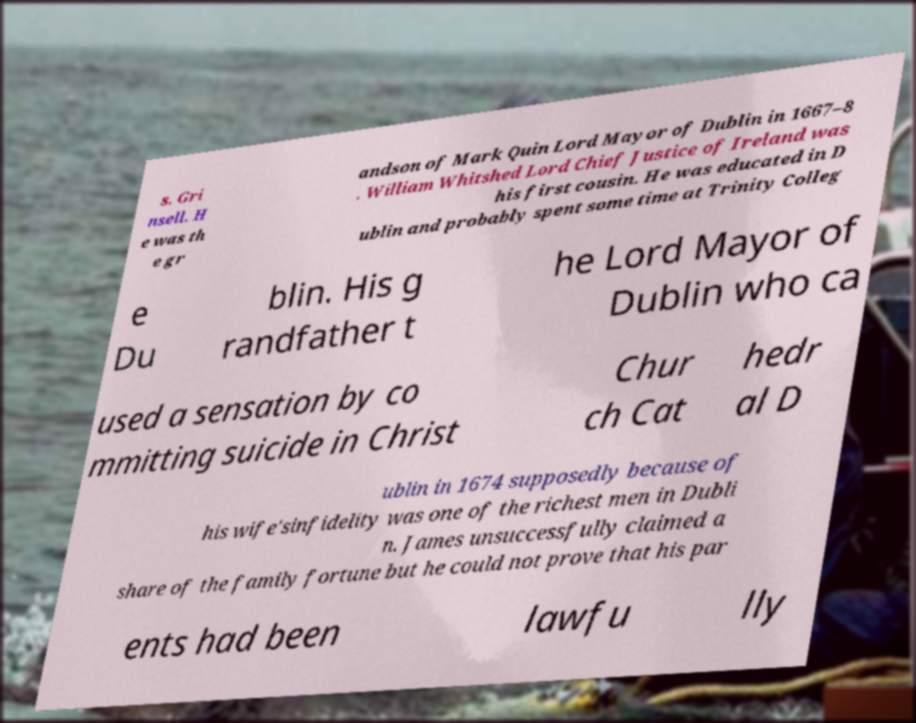Could you extract and type out the text from this image? s. Gri nsell. H e was th e gr andson of Mark Quin Lord Mayor of Dublin in 1667–8 . William Whitshed Lord Chief Justice of Ireland was his first cousin. He was educated in D ublin and probably spent some time at Trinity Colleg e Du blin. His g randfather t he Lord Mayor of Dublin who ca used a sensation by co mmitting suicide in Christ Chur ch Cat hedr al D ublin in 1674 supposedly because of his wife'sinfidelity was one of the richest men in Dubli n. James unsuccessfully claimed a share of the family fortune but he could not prove that his par ents had been lawfu lly 